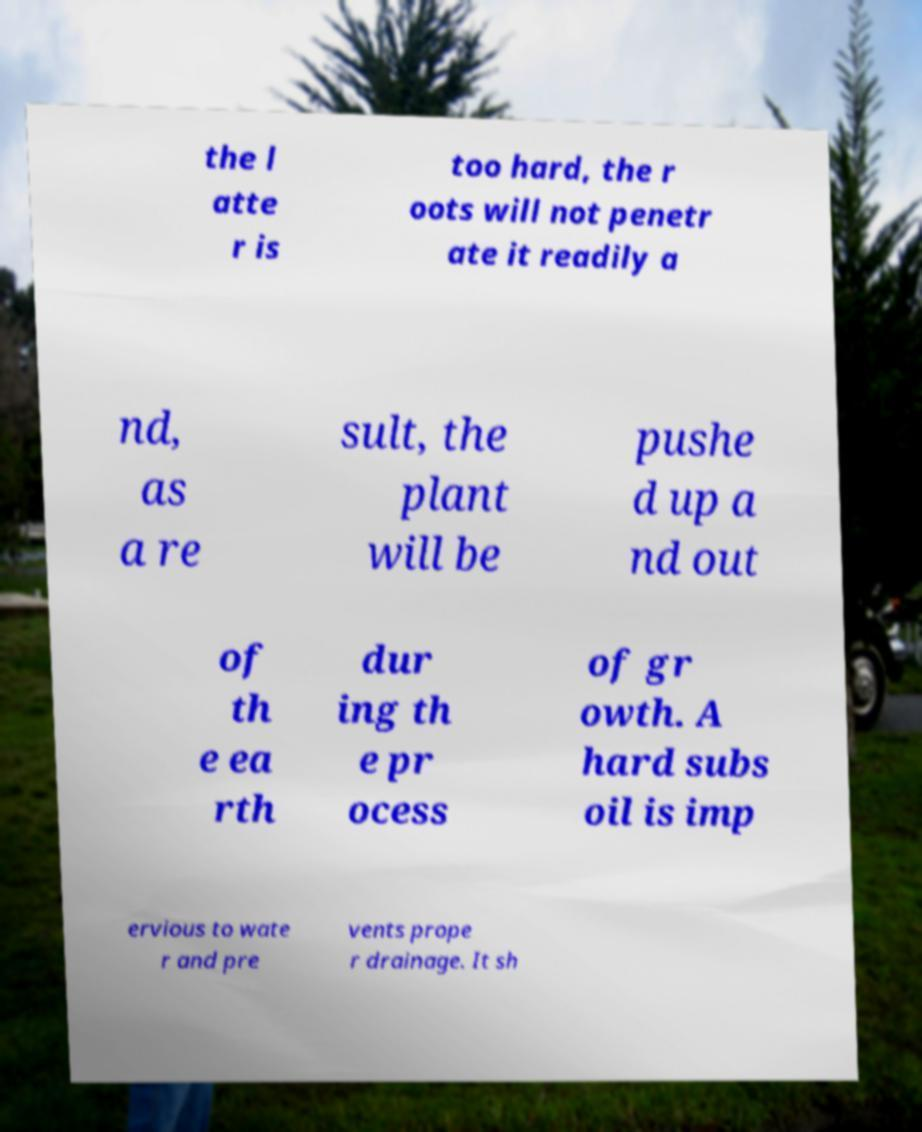I need the written content from this picture converted into text. Can you do that? the l atte r is too hard, the r oots will not penetr ate it readily a nd, as a re sult, the plant will be pushe d up a nd out of th e ea rth dur ing th e pr ocess of gr owth. A hard subs oil is imp ervious to wate r and pre vents prope r drainage. It sh 